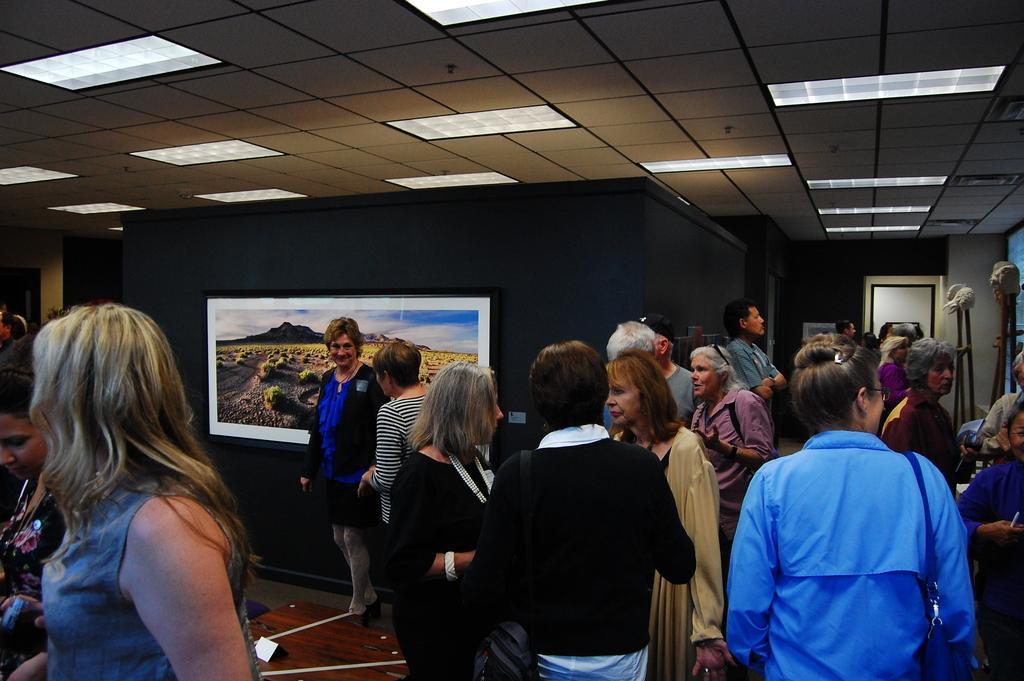Describe this image in one or two sentences. In this image, there are groups of people standing. This is a photo frame, which is attached to the wall. On the right side of the image, I can see the objects with the stands. In the background, I think this is the door. These are the ceiling lights, which are attached to the ceiling. At the bottom of the image, that looks like a wooden table. 